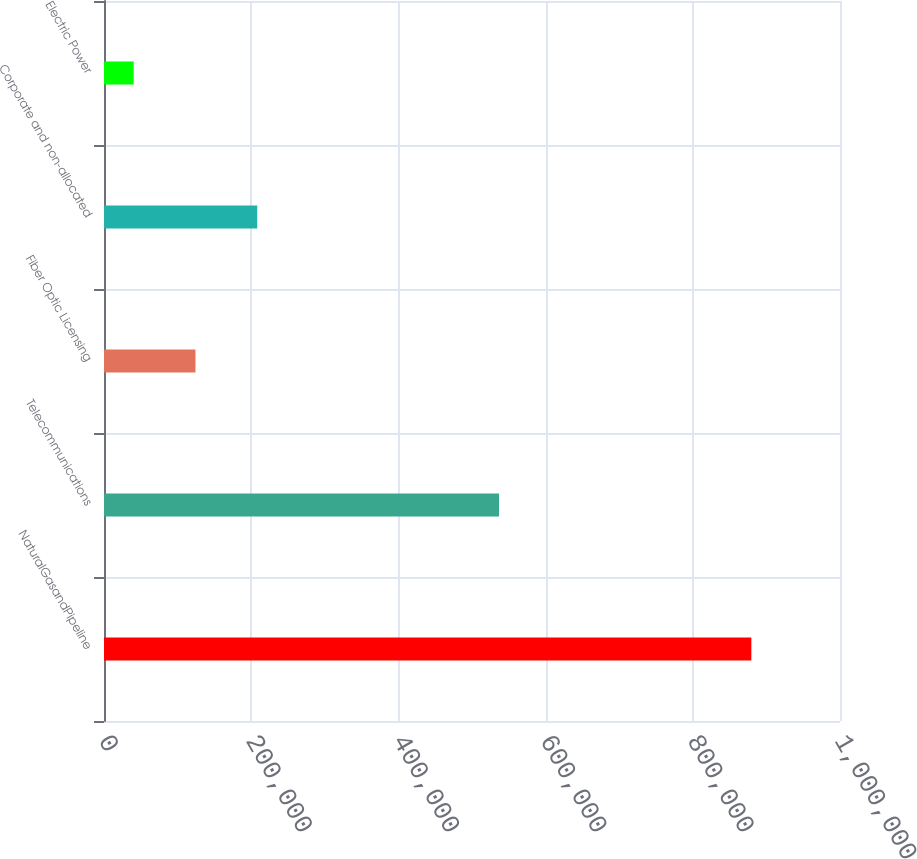Convert chart to OTSL. <chart><loc_0><loc_0><loc_500><loc_500><bar_chart><fcel>NaturalGasandPipeline<fcel>Telecommunications<fcel>Fiber Optic Licensing<fcel>Corporate and non-allocated<fcel>Electric Power<nl><fcel>879541<fcel>536778<fcel>124276<fcel>208195<fcel>40358<nl></chart> 